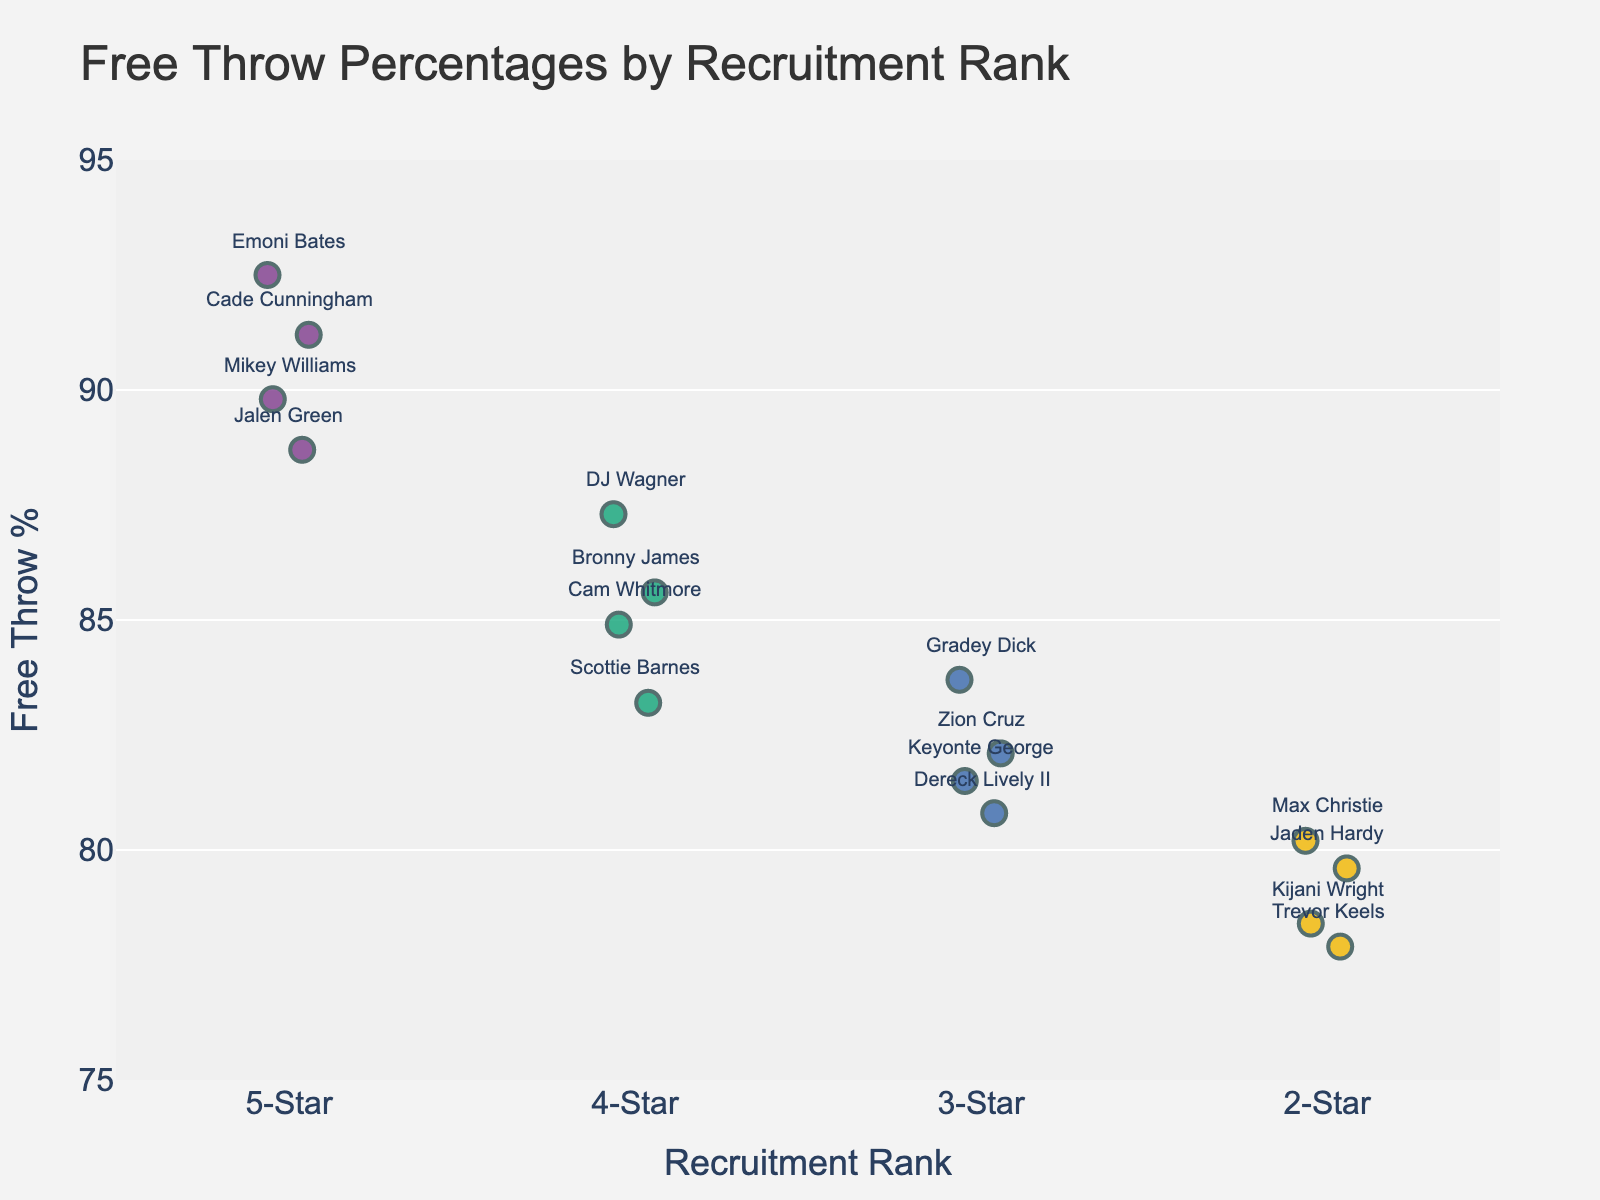What is the title of the figure? The title is located at the top of the figure and usually describes what the figure is about. In this case, it is given in the code that generates the figure.
Answer: Free Throw Percentages by Recruitment Rank How many 5-star players are shown in the plot? To find the answer, look at the x-axis where the 5-Star category is located and count the number of data points (markers) there.
Answer: 4 Who is the player with the highest free throw percentage? Identify the highest point on the y-axis, then check the annotation next to it for the player's name.
Answer: Emoni Bates What is the range of free throw percentages for 2-star players? Look at the spread of markers in the 2-Star category on the x-axis and note the minimum and maximum y-axis values among them. The minimum is 77.9% and the maximum is 80.2%.
Answer: 77.9% to 80.2% Which recruitment rank category has the highest number of players with a free throw percentage above 90%? Check each category on the x-axis for data points above the 90% mark on the y-axis. Only the 5-Star category has data points above 90%.
Answer: 5-Star What is the average free throw percentage for 4-star players? Add up the free throw percentages of all 4-Star players: 85.6 + 87.3 + 84.9 + 83.2 = 341. Then divide by the number of players: 341 / 4 = 85.25.
Answer: 85.25% How does the free throw percentage of the best 3-star player compare to the worst 4-star player? Identify the highest point in the 3-Star category and the lowest point in the 4-Star category, then compare their values. The best 3-star is Gradey Dick at 83.7%, and the worst 4-star is Scottie Barnes at 83.2%.
Answer: Gradey Dick has a 0.5% higher percentage than Scottie Barnes Does any recruitment rank have more than one player with the same free throw percentage? Observe each category on the x-axis to see if any data points overlap vertically, indicating the same percentage.
Answer: No What is the difference in free throw percentage between Mikey Williams and Max Christie? Find Mikey Williams' percentage (89.8%) and Max Christie's percentage (80.2%), then subtract the smaller number from the larger: 89.8 - 80.2 = 9.6.
Answer: 9.6% In which recruitment rank category is there the least variation in free throw percentages? Look at the spread of markers in each category and identify which has the smallest range of y-axis values. The 2-Star category has the least variation with a range from 77.9% to 80.2%.
Answer: 2-Star 